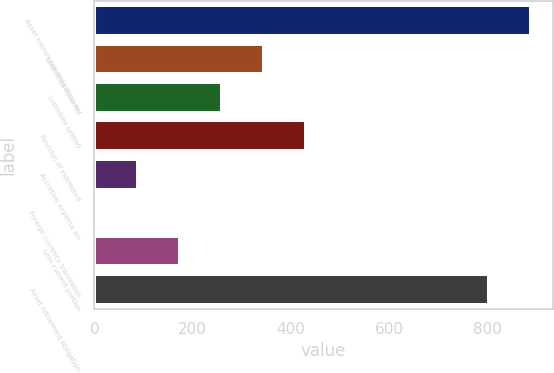Convert chart. <chart><loc_0><loc_0><loc_500><loc_500><bar_chart><fcel>Asset retirement obligation as<fcel>Liabilities incurred<fcel>Liabilities settled<fcel>Revision of estimated<fcel>Accretion expense on<fcel>Foreign currency translation<fcel>Less current portion<fcel>Asset retirement obligation<nl><fcel>889.3<fcel>345.2<fcel>259.9<fcel>430.5<fcel>89.3<fcel>4<fcel>174.6<fcel>804<nl></chart> 